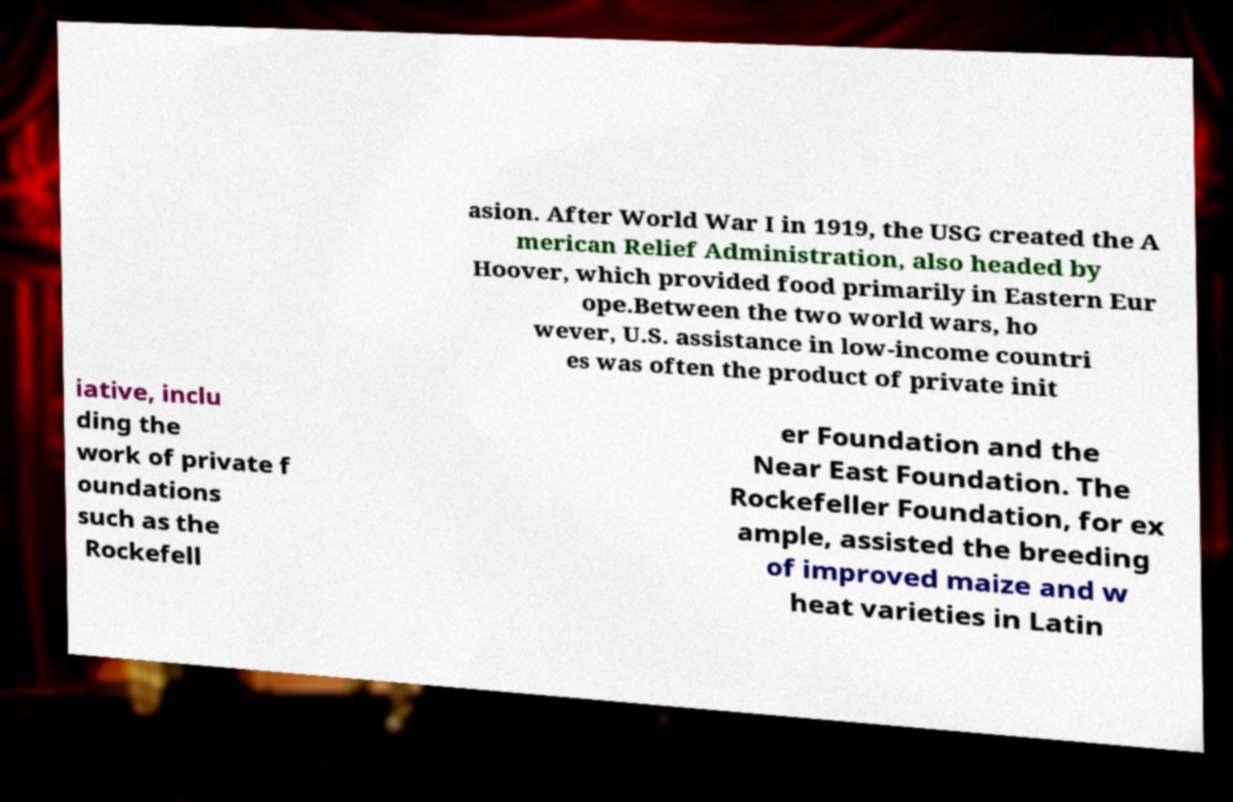What messages or text are displayed in this image? I need them in a readable, typed format. asion. After World War I in 1919, the USG created the A merican Relief Administration, also headed by Hoover, which provided food primarily in Eastern Eur ope.Between the two world wars, ho wever, U.S. assistance in low-income countri es was often the product of private init iative, inclu ding the work of private f oundations such as the Rockefell er Foundation and the Near East Foundation. The Rockefeller Foundation, for ex ample, assisted the breeding of improved maize and w heat varieties in Latin 